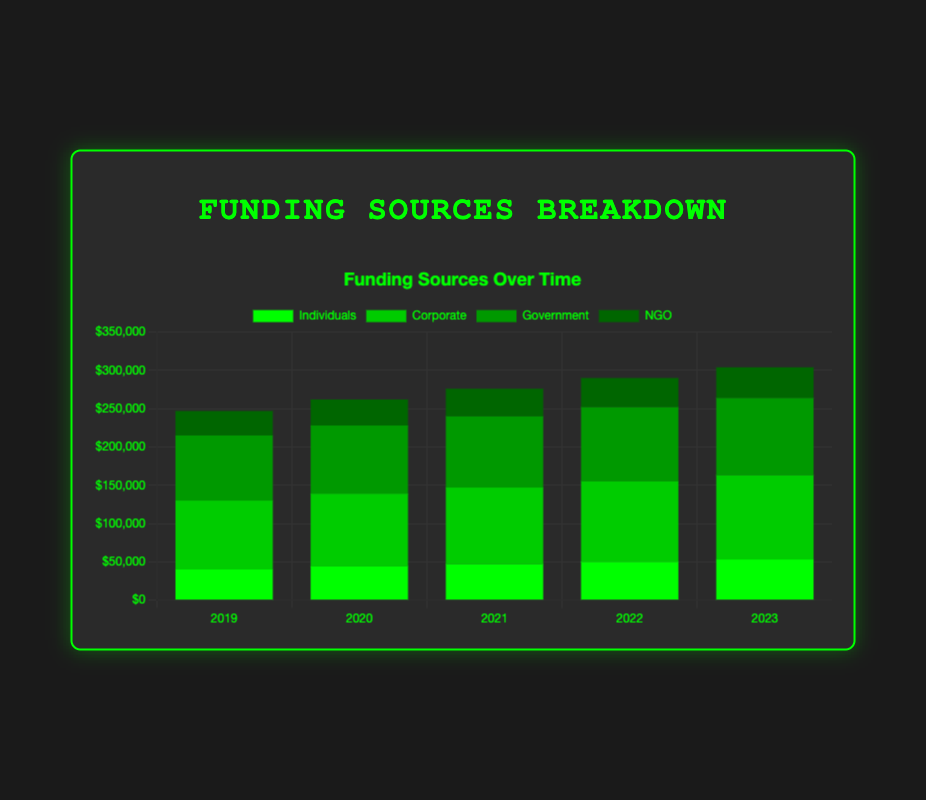Which contributor type had the highest total funding in 2023? Add up the contributions of each contributor type for 2023: Individuals: 17000 + 22000 + 14000 = 53000, Corporate: 43000 + 38000 + 29000 = 110000, Government: 58000 + 43000 = 101000, NGO: 19000 + 21000 = 40000. The Corporate contributors have the highest total funding of 110000 in 2023.
Answer: Corporate How did individual funding change from 2019 to 2023? Calculate the total individual funding for 2019 and 2023 and compare them. For 2019: 12000 + 18000 + 10000 = 40000, and for 2023: 17000 + 22000 + 14000 = 53000. The change is 53000 - 40000 = 13000. Individual funding increased by 13000 from 2019 to 2023.
Answer: Increased by 13000 What is the average annual total funding from NGOs over the 5-year period? First, calculate the total funding for each year from NGOs and then find the average. For 2019: 15000 + 17000 = 32000, 2020: 16000 + 18000 = 34000, 2021: 17000 + 19000 = 36000, 2022: 18000 + 20000 = 38000, 2023: 19000 + 21000 = 40000. Sum these totals: 32000 + 34000 + 36000 + 38000 + 40000 = 180000, then divide by 5 (the number of years) to get the average: 180000 / 5 = 36000.
Answer: 36000 Which segment had a constant increase in funding each year? Examine the yearly funding trend for each segment to determine which has a consistent increase. Individuals: John Doe: 12000 → 14000 → 15000 → 16000 → 17000, Jane Smith: 18000 → 19000 → 20000 → 21000 → 22000, Michael Brown: 10000 → 11000 → 12000 → 13000 → 14000; Corporate followers, NGOs; but Government shows consistent annual increase: Federal Grant: 50000 → 52000 → 54000 → 56000 → 58000, State Subsidy: 35000 → 37000 → 39000 → 41000 → 43000. Both Government sources have consistent yearly increases.
Answer: Government Compare the funding growth rates of TechCorp Inc. and FinServ Ltd. from 2019 to 2023. Calculate the funding for both companies in 2019 and 2023, then compute the growth rate. TechCorp Inc.: (43000 - 35000) / 35000 * 100 = 22.86% increase, FinServ Ltd.: (38000 - 30000) / 30000 * 100 = 26.67% increase. FinServ Ltd. has slightly higher growth rate than TechCorp Inc.
Answer: FinServ Ltd. has a higher growth rate Which contributor contributed the most in 2021? Compare contributions of all contributors in 2021: John Doe: 15000, Jane Smith: 20000, Michael Brown: 12000, TechCorp Inc.: 39000, FinServ Ltd.: 34000, HealthMed LLC: 27000, Federal Grant: 54000, State Subsidy: 39000, CharityOne: 17000, AidHelping Hands: 19000. Federal Grant has the highest contribution of 54000 in 2021.
Answer: Federal Grant What is the overall trend for total funding from years 2019 to 2023? Sum up the yearly totals of all contributor types for each year and identify the trend. For 2019: 40000 + 90000 + 85000 + 32000 = 247000, for 2020: 44000 + 95000 + 89000 + 34000 = 262000, for 2021: 47000 + 100000 + 93000 + 36000 = 276000, for 2022: 50000 + 105000 + 97000 + 38000 = 290000, for 2023: 53000 + 110000 + 101000 + 40000 = 304000. The funding is increasing each year.
Answer: Increasing 